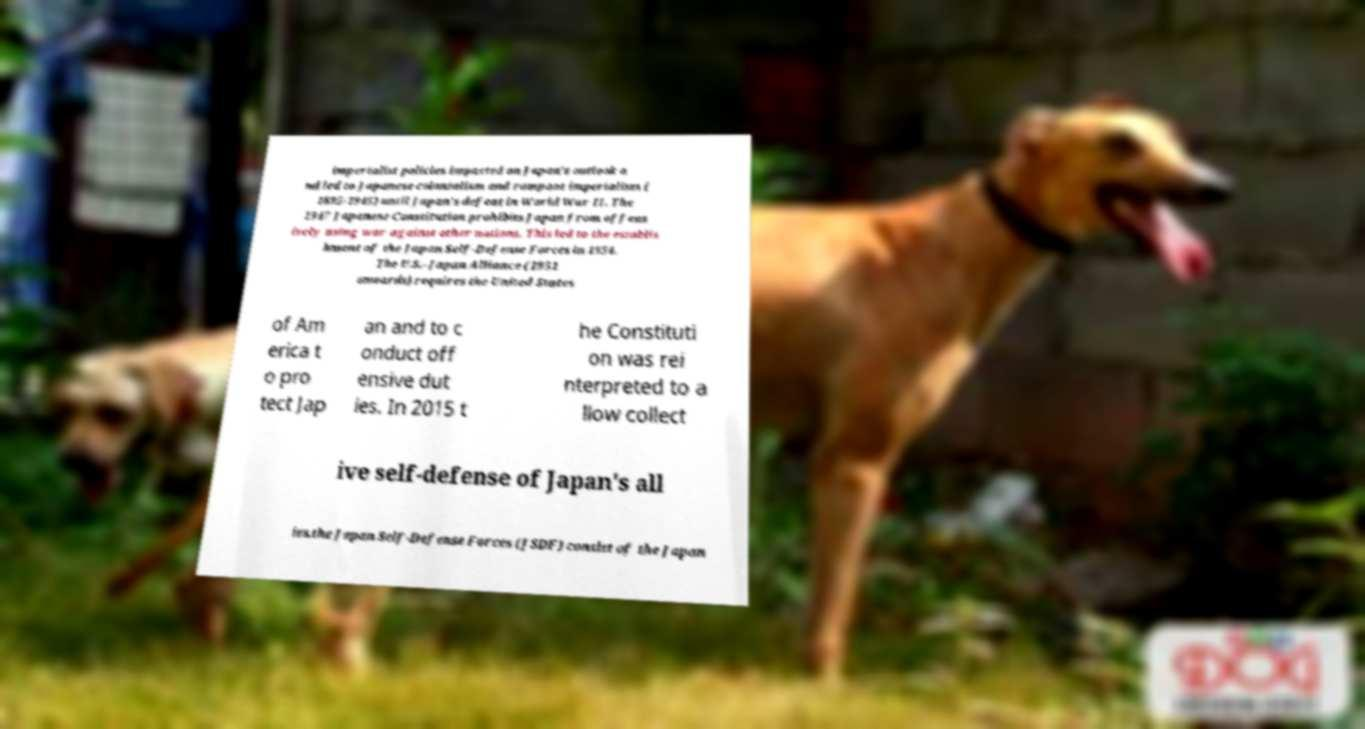Could you assist in decoding the text presented in this image and type it out clearly? imperialist policies impacted on Japan's outlook a nd led to Japanese colonialism and rampant imperialism ( 1895-1945) until Japan's defeat in World War II. The 1947 Japanese Constitution prohibits Japan from offens ively using war against other nations. This led to the establis hment of the Japan Self-Defense Forces in 1954. The U.S.–Japan Alliance (1951 onwards) requires the United States of Am erica t o pro tect Jap an and to c onduct off ensive dut ies. In 2015 t he Constituti on was rei nterpreted to a llow collect ive self-defense of Japan's all ies.the Japan Self-Defense Forces (JSDF) consist of the Japan 